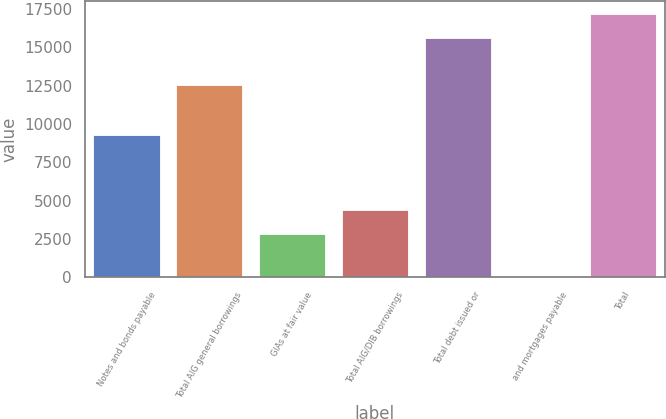<chart> <loc_0><loc_0><loc_500><loc_500><bar_chart><fcel>Notes and bonds payable<fcel>Total AIG general borrowings<fcel>GIAs at fair value<fcel>Total AIG/DIB borrowings<fcel>Total debt issued or<fcel>and mortgages payable<fcel>Total<nl><fcel>9254<fcel>12540<fcel>2827<fcel>4389.5<fcel>15625<fcel>16<fcel>17187.5<nl></chart> 